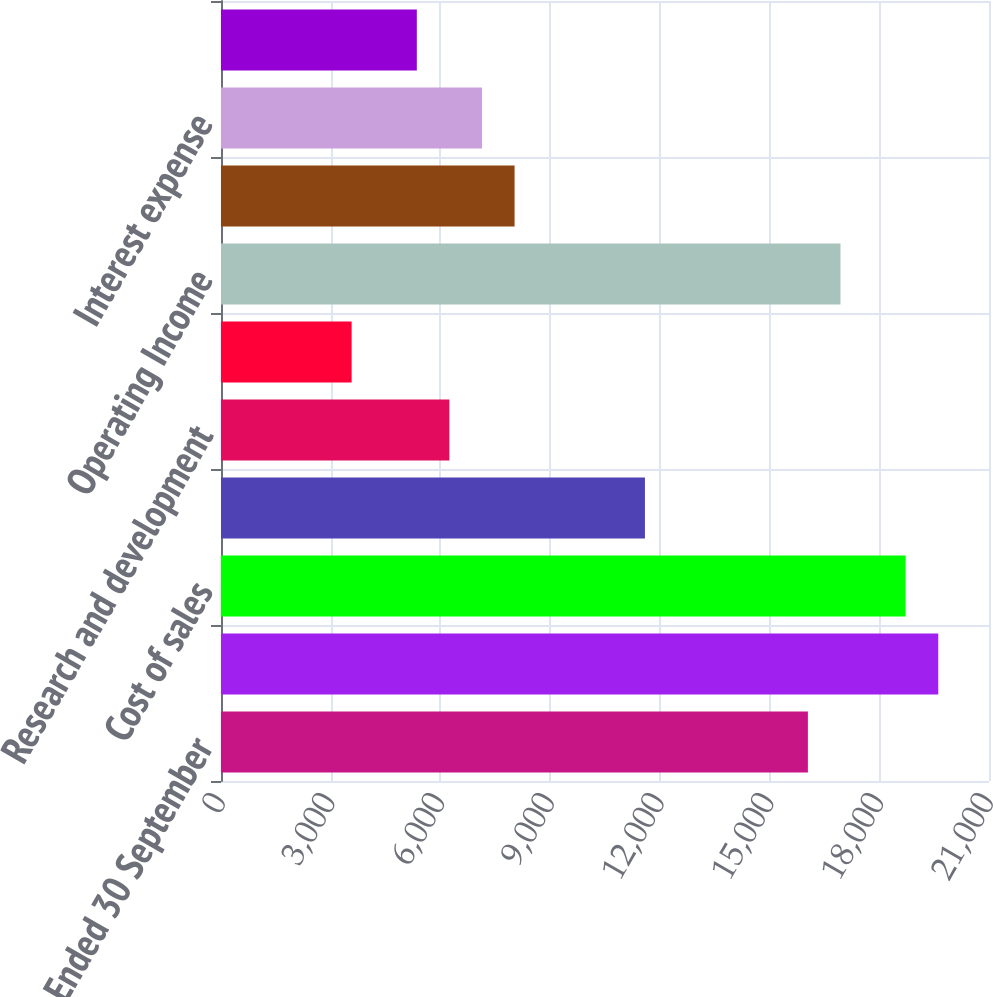<chart> <loc_0><loc_0><loc_500><loc_500><bar_chart><fcel>Year Ended 30 September<fcel>Sales<fcel>Cost of sales<fcel>Selling and administrative<fcel>Research and development<fcel>Other income (expense) net<fcel>Operating Income<fcel>Equity affiliates' income<fcel>Interest expense<fcel>Other non-operating income<nl><fcel>16047.7<fcel>19612.1<fcel>18721<fcel>11592.2<fcel>6245.64<fcel>3572.34<fcel>16938.8<fcel>8027.84<fcel>7136.74<fcel>5354.54<nl></chart> 